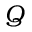Convert formula to latex. <formula><loc_0><loc_0><loc_500><loc_500>Q</formula> 